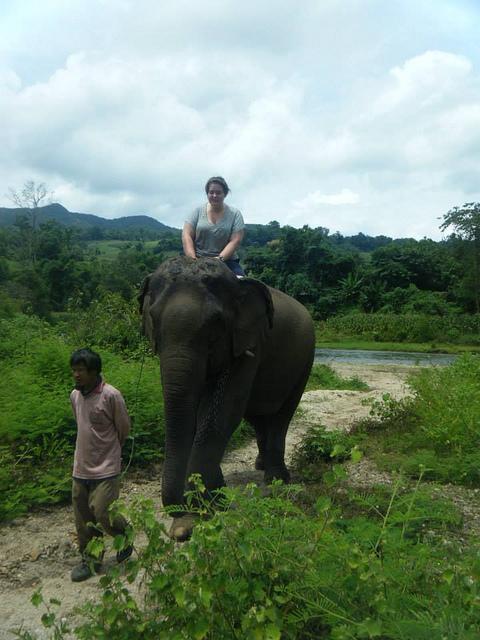How many people are there?
Give a very brief answer. 2. 